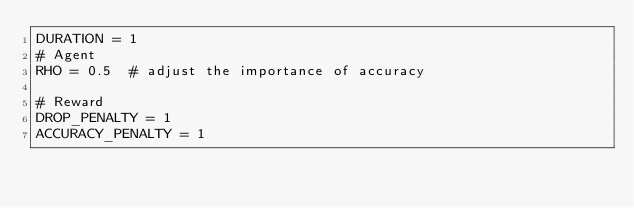Convert code to text. <code><loc_0><loc_0><loc_500><loc_500><_Python_>DURATION = 1
# Agent
RHO = 0.5  # adjust the importance of accuracy

# Reward
DROP_PENALTY = 1
ACCURACY_PENALTY = 1</code> 